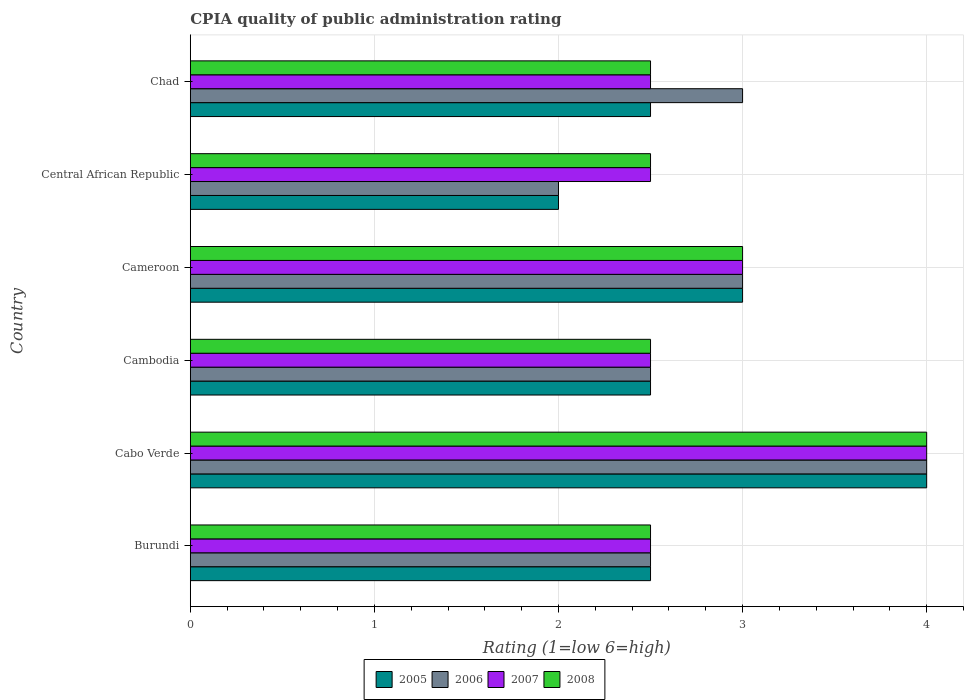How many different coloured bars are there?
Your response must be concise. 4. How many groups of bars are there?
Give a very brief answer. 6. Are the number of bars per tick equal to the number of legend labels?
Ensure brevity in your answer.  Yes. How many bars are there on the 6th tick from the bottom?
Give a very brief answer. 4. What is the label of the 2nd group of bars from the top?
Your answer should be very brief. Central African Republic. In how many cases, is the number of bars for a given country not equal to the number of legend labels?
Ensure brevity in your answer.  0. What is the CPIA rating in 2008 in Chad?
Ensure brevity in your answer.  2.5. Across all countries, what is the minimum CPIA rating in 2008?
Keep it short and to the point. 2.5. In which country was the CPIA rating in 2006 maximum?
Offer a terse response. Cabo Verde. In which country was the CPIA rating in 2007 minimum?
Offer a very short reply. Burundi. What is the difference between the CPIA rating in 2006 in Burundi and that in Cambodia?
Offer a very short reply. 0. What is the average CPIA rating in 2006 per country?
Offer a very short reply. 2.83. In how many countries, is the CPIA rating in 2007 greater than 2.6 ?
Offer a very short reply. 2. What is the ratio of the CPIA rating in 2005 in Central African Republic to that in Chad?
Make the answer very short. 0.8. Is the difference between the CPIA rating in 2008 in Cameroon and Chad greater than the difference between the CPIA rating in 2006 in Cameroon and Chad?
Give a very brief answer. Yes. What is the difference between the highest and the second highest CPIA rating in 2008?
Offer a terse response. 1. What is the difference between the highest and the lowest CPIA rating in 2005?
Make the answer very short. 2. Is it the case that in every country, the sum of the CPIA rating in 2007 and CPIA rating in 2006 is greater than the sum of CPIA rating in 2005 and CPIA rating in 2008?
Offer a very short reply. No. Is it the case that in every country, the sum of the CPIA rating in 2005 and CPIA rating in 2008 is greater than the CPIA rating in 2006?
Give a very brief answer. Yes. How many bars are there?
Keep it short and to the point. 24. How many countries are there in the graph?
Give a very brief answer. 6. What is the difference between two consecutive major ticks on the X-axis?
Give a very brief answer. 1. Where does the legend appear in the graph?
Offer a very short reply. Bottom center. How many legend labels are there?
Your answer should be very brief. 4. What is the title of the graph?
Ensure brevity in your answer.  CPIA quality of public administration rating. What is the Rating (1=low 6=high) in 2006 in Burundi?
Your answer should be compact. 2.5. What is the Rating (1=low 6=high) of 2007 in Burundi?
Provide a short and direct response. 2.5. What is the Rating (1=low 6=high) in 2005 in Cabo Verde?
Your answer should be compact. 4. What is the Rating (1=low 6=high) in 2006 in Cabo Verde?
Make the answer very short. 4. What is the Rating (1=low 6=high) in 2008 in Cabo Verde?
Your answer should be compact. 4. What is the Rating (1=low 6=high) in 2006 in Cambodia?
Provide a succinct answer. 2.5. What is the Rating (1=low 6=high) of 2006 in Cameroon?
Your answer should be compact. 3. What is the Rating (1=low 6=high) of 2007 in Cameroon?
Ensure brevity in your answer.  3. What is the Rating (1=low 6=high) in 2005 in Central African Republic?
Offer a terse response. 2. What is the Rating (1=low 6=high) in 2006 in Central African Republic?
Your answer should be very brief. 2. What is the Rating (1=low 6=high) of 2008 in Central African Republic?
Offer a very short reply. 2.5. What is the Rating (1=low 6=high) of 2005 in Chad?
Your answer should be compact. 2.5. What is the Rating (1=low 6=high) in 2006 in Chad?
Ensure brevity in your answer.  3. What is the Rating (1=low 6=high) of 2008 in Chad?
Make the answer very short. 2.5. Across all countries, what is the maximum Rating (1=low 6=high) of 2005?
Make the answer very short. 4. Across all countries, what is the maximum Rating (1=low 6=high) in 2006?
Give a very brief answer. 4. Across all countries, what is the minimum Rating (1=low 6=high) of 2005?
Offer a terse response. 2. Across all countries, what is the minimum Rating (1=low 6=high) in 2006?
Provide a succinct answer. 2. Across all countries, what is the minimum Rating (1=low 6=high) of 2008?
Offer a terse response. 2.5. What is the total Rating (1=low 6=high) of 2005 in the graph?
Ensure brevity in your answer.  16.5. What is the total Rating (1=low 6=high) in 2006 in the graph?
Give a very brief answer. 17. What is the total Rating (1=low 6=high) of 2008 in the graph?
Provide a succinct answer. 17. What is the difference between the Rating (1=low 6=high) in 2005 in Burundi and that in Cabo Verde?
Provide a short and direct response. -1.5. What is the difference between the Rating (1=low 6=high) in 2006 in Burundi and that in Cabo Verde?
Make the answer very short. -1.5. What is the difference between the Rating (1=low 6=high) of 2005 in Burundi and that in Cambodia?
Your answer should be compact. 0. What is the difference between the Rating (1=low 6=high) of 2005 in Burundi and that in Cameroon?
Give a very brief answer. -0.5. What is the difference between the Rating (1=low 6=high) of 2007 in Burundi and that in Cameroon?
Your response must be concise. -0.5. What is the difference between the Rating (1=low 6=high) in 2005 in Burundi and that in Central African Republic?
Make the answer very short. 0.5. What is the difference between the Rating (1=low 6=high) in 2005 in Burundi and that in Chad?
Give a very brief answer. 0. What is the difference between the Rating (1=low 6=high) in 2006 in Burundi and that in Chad?
Your response must be concise. -0.5. What is the difference between the Rating (1=low 6=high) in 2007 in Burundi and that in Chad?
Offer a very short reply. 0. What is the difference between the Rating (1=low 6=high) in 2008 in Burundi and that in Chad?
Your response must be concise. 0. What is the difference between the Rating (1=low 6=high) in 2005 in Cabo Verde and that in Cambodia?
Keep it short and to the point. 1.5. What is the difference between the Rating (1=low 6=high) of 2006 in Cabo Verde and that in Cambodia?
Your answer should be very brief. 1.5. What is the difference between the Rating (1=low 6=high) of 2006 in Cabo Verde and that in Cameroon?
Your answer should be compact. 1. What is the difference between the Rating (1=low 6=high) of 2007 in Cabo Verde and that in Cameroon?
Give a very brief answer. 1. What is the difference between the Rating (1=low 6=high) of 2005 in Cabo Verde and that in Central African Republic?
Your answer should be compact. 2. What is the difference between the Rating (1=low 6=high) of 2007 in Cabo Verde and that in Central African Republic?
Offer a terse response. 1.5. What is the difference between the Rating (1=low 6=high) of 2008 in Cabo Verde and that in Central African Republic?
Provide a short and direct response. 1.5. What is the difference between the Rating (1=low 6=high) of 2007 in Cabo Verde and that in Chad?
Offer a terse response. 1.5. What is the difference between the Rating (1=low 6=high) in 2006 in Cambodia and that in Cameroon?
Make the answer very short. -0.5. What is the difference between the Rating (1=low 6=high) in 2007 in Cambodia and that in Cameroon?
Your answer should be compact. -0.5. What is the difference between the Rating (1=low 6=high) in 2005 in Cambodia and that in Central African Republic?
Make the answer very short. 0.5. What is the difference between the Rating (1=low 6=high) of 2006 in Cambodia and that in Central African Republic?
Keep it short and to the point. 0.5. What is the difference between the Rating (1=low 6=high) in 2008 in Cambodia and that in Chad?
Make the answer very short. 0. What is the difference between the Rating (1=low 6=high) in 2006 in Cameroon and that in Central African Republic?
Your response must be concise. 1. What is the difference between the Rating (1=low 6=high) of 2005 in Cameroon and that in Chad?
Your answer should be compact. 0.5. What is the difference between the Rating (1=low 6=high) in 2006 in Cameroon and that in Chad?
Provide a short and direct response. 0. What is the difference between the Rating (1=low 6=high) in 2007 in Cameroon and that in Chad?
Provide a short and direct response. 0.5. What is the difference between the Rating (1=low 6=high) of 2008 in Cameroon and that in Chad?
Keep it short and to the point. 0.5. What is the difference between the Rating (1=low 6=high) in 2007 in Central African Republic and that in Chad?
Ensure brevity in your answer.  0. What is the difference between the Rating (1=low 6=high) of 2005 in Burundi and the Rating (1=low 6=high) of 2007 in Cabo Verde?
Offer a very short reply. -1.5. What is the difference between the Rating (1=low 6=high) of 2006 in Burundi and the Rating (1=low 6=high) of 2008 in Cabo Verde?
Provide a succinct answer. -1.5. What is the difference between the Rating (1=low 6=high) in 2007 in Burundi and the Rating (1=low 6=high) in 2008 in Cabo Verde?
Offer a very short reply. -1.5. What is the difference between the Rating (1=low 6=high) of 2006 in Burundi and the Rating (1=low 6=high) of 2008 in Cambodia?
Provide a succinct answer. 0. What is the difference between the Rating (1=low 6=high) in 2007 in Burundi and the Rating (1=low 6=high) in 2008 in Cambodia?
Make the answer very short. 0. What is the difference between the Rating (1=low 6=high) in 2005 in Burundi and the Rating (1=low 6=high) in 2006 in Cameroon?
Make the answer very short. -0.5. What is the difference between the Rating (1=low 6=high) in 2005 in Burundi and the Rating (1=low 6=high) in 2008 in Cameroon?
Make the answer very short. -0.5. What is the difference between the Rating (1=low 6=high) of 2005 in Burundi and the Rating (1=low 6=high) of 2007 in Chad?
Offer a very short reply. 0. What is the difference between the Rating (1=low 6=high) of 2005 in Burundi and the Rating (1=low 6=high) of 2008 in Chad?
Give a very brief answer. 0. What is the difference between the Rating (1=low 6=high) in 2006 in Burundi and the Rating (1=low 6=high) in 2007 in Chad?
Provide a succinct answer. 0. What is the difference between the Rating (1=low 6=high) in 2006 in Burundi and the Rating (1=low 6=high) in 2008 in Chad?
Your answer should be compact. 0. What is the difference between the Rating (1=low 6=high) in 2005 in Cabo Verde and the Rating (1=low 6=high) in 2006 in Cambodia?
Ensure brevity in your answer.  1.5. What is the difference between the Rating (1=low 6=high) in 2005 in Cabo Verde and the Rating (1=low 6=high) in 2008 in Cambodia?
Offer a very short reply. 1.5. What is the difference between the Rating (1=low 6=high) of 2006 in Cabo Verde and the Rating (1=low 6=high) of 2007 in Cambodia?
Provide a short and direct response. 1.5. What is the difference between the Rating (1=low 6=high) of 2006 in Cabo Verde and the Rating (1=low 6=high) of 2008 in Cambodia?
Your response must be concise. 1.5. What is the difference between the Rating (1=low 6=high) in 2007 in Cabo Verde and the Rating (1=low 6=high) in 2008 in Cambodia?
Your response must be concise. 1.5. What is the difference between the Rating (1=low 6=high) of 2005 in Cabo Verde and the Rating (1=low 6=high) of 2007 in Cameroon?
Keep it short and to the point. 1. What is the difference between the Rating (1=low 6=high) of 2006 in Cabo Verde and the Rating (1=low 6=high) of 2007 in Cameroon?
Your answer should be compact. 1. What is the difference between the Rating (1=low 6=high) of 2006 in Cabo Verde and the Rating (1=low 6=high) of 2008 in Cameroon?
Provide a succinct answer. 1. What is the difference between the Rating (1=low 6=high) in 2005 in Cabo Verde and the Rating (1=low 6=high) in 2008 in Central African Republic?
Your answer should be compact. 1.5. What is the difference between the Rating (1=low 6=high) of 2006 in Cabo Verde and the Rating (1=low 6=high) of 2008 in Central African Republic?
Offer a terse response. 1.5. What is the difference between the Rating (1=low 6=high) in 2005 in Cabo Verde and the Rating (1=low 6=high) in 2006 in Chad?
Keep it short and to the point. 1. What is the difference between the Rating (1=low 6=high) in 2005 in Cabo Verde and the Rating (1=low 6=high) in 2007 in Chad?
Offer a very short reply. 1.5. What is the difference between the Rating (1=low 6=high) in 2006 in Cabo Verde and the Rating (1=low 6=high) in 2008 in Chad?
Ensure brevity in your answer.  1.5. What is the difference between the Rating (1=low 6=high) in 2005 in Cambodia and the Rating (1=low 6=high) in 2006 in Cameroon?
Ensure brevity in your answer.  -0.5. What is the difference between the Rating (1=low 6=high) of 2005 in Cambodia and the Rating (1=low 6=high) of 2007 in Cameroon?
Your answer should be compact. -0.5. What is the difference between the Rating (1=low 6=high) in 2006 in Cambodia and the Rating (1=low 6=high) in 2007 in Cameroon?
Offer a terse response. -0.5. What is the difference between the Rating (1=low 6=high) of 2007 in Cambodia and the Rating (1=low 6=high) of 2008 in Cameroon?
Offer a terse response. -0.5. What is the difference between the Rating (1=low 6=high) in 2005 in Cambodia and the Rating (1=low 6=high) in 2006 in Central African Republic?
Provide a short and direct response. 0.5. What is the difference between the Rating (1=low 6=high) in 2005 in Cambodia and the Rating (1=low 6=high) in 2007 in Central African Republic?
Your response must be concise. 0. What is the difference between the Rating (1=low 6=high) of 2006 in Cambodia and the Rating (1=low 6=high) of 2008 in Central African Republic?
Ensure brevity in your answer.  0. What is the difference between the Rating (1=low 6=high) in 2005 in Cambodia and the Rating (1=low 6=high) in 2006 in Chad?
Your answer should be compact. -0.5. What is the difference between the Rating (1=low 6=high) of 2005 in Cambodia and the Rating (1=low 6=high) of 2007 in Chad?
Keep it short and to the point. 0. What is the difference between the Rating (1=low 6=high) of 2005 in Cambodia and the Rating (1=low 6=high) of 2008 in Chad?
Your response must be concise. 0. What is the difference between the Rating (1=low 6=high) in 2006 in Cambodia and the Rating (1=low 6=high) in 2007 in Chad?
Make the answer very short. 0. What is the difference between the Rating (1=low 6=high) in 2006 in Cambodia and the Rating (1=low 6=high) in 2008 in Chad?
Offer a very short reply. 0. What is the difference between the Rating (1=low 6=high) in 2007 in Cambodia and the Rating (1=low 6=high) in 2008 in Chad?
Offer a terse response. 0. What is the difference between the Rating (1=low 6=high) in 2005 in Cameroon and the Rating (1=low 6=high) in 2006 in Central African Republic?
Provide a short and direct response. 1. What is the difference between the Rating (1=low 6=high) of 2005 in Cameroon and the Rating (1=low 6=high) of 2008 in Central African Republic?
Offer a terse response. 0.5. What is the difference between the Rating (1=low 6=high) in 2006 in Cameroon and the Rating (1=low 6=high) in 2007 in Central African Republic?
Your answer should be very brief. 0.5. What is the difference between the Rating (1=low 6=high) of 2006 in Cameroon and the Rating (1=low 6=high) of 2008 in Central African Republic?
Your response must be concise. 0.5. What is the difference between the Rating (1=low 6=high) in 2007 in Cameroon and the Rating (1=low 6=high) in 2008 in Central African Republic?
Provide a succinct answer. 0.5. What is the difference between the Rating (1=low 6=high) in 2005 in Cameroon and the Rating (1=low 6=high) in 2007 in Chad?
Ensure brevity in your answer.  0.5. What is the difference between the Rating (1=low 6=high) of 2006 in Cameroon and the Rating (1=low 6=high) of 2008 in Chad?
Offer a terse response. 0.5. What is the difference between the Rating (1=low 6=high) in 2007 in Cameroon and the Rating (1=low 6=high) in 2008 in Chad?
Keep it short and to the point. 0.5. What is the difference between the Rating (1=low 6=high) in 2005 in Central African Republic and the Rating (1=low 6=high) in 2007 in Chad?
Provide a short and direct response. -0.5. What is the difference between the Rating (1=low 6=high) in 2005 in Central African Republic and the Rating (1=low 6=high) in 2008 in Chad?
Offer a terse response. -0.5. What is the difference between the Rating (1=low 6=high) in 2006 in Central African Republic and the Rating (1=low 6=high) in 2007 in Chad?
Your answer should be very brief. -0.5. What is the average Rating (1=low 6=high) in 2005 per country?
Your answer should be compact. 2.75. What is the average Rating (1=low 6=high) in 2006 per country?
Ensure brevity in your answer.  2.83. What is the average Rating (1=low 6=high) in 2007 per country?
Ensure brevity in your answer.  2.83. What is the average Rating (1=low 6=high) in 2008 per country?
Give a very brief answer. 2.83. What is the difference between the Rating (1=low 6=high) of 2005 and Rating (1=low 6=high) of 2008 in Burundi?
Your answer should be very brief. 0. What is the difference between the Rating (1=low 6=high) of 2006 and Rating (1=low 6=high) of 2007 in Burundi?
Your response must be concise. 0. What is the difference between the Rating (1=low 6=high) of 2006 and Rating (1=low 6=high) of 2008 in Burundi?
Your answer should be compact. 0. What is the difference between the Rating (1=low 6=high) in 2007 and Rating (1=low 6=high) in 2008 in Burundi?
Ensure brevity in your answer.  0. What is the difference between the Rating (1=low 6=high) of 2005 and Rating (1=low 6=high) of 2006 in Cabo Verde?
Offer a very short reply. 0. What is the difference between the Rating (1=low 6=high) of 2005 and Rating (1=low 6=high) of 2008 in Cabo Verde?
Make the answer very short. 0. What is the difference between the Rating (1=low 6=high) of 2006 and Rating (1=low 6=high) of 2007 in Cabo Verde?
Your answer should be compact. 0. What is the difference between the Rating (1=low 6=high) of 2006 and Rating (1=low 6=high) of 2008 in Cabo Verde?
Ensure brevity in your answer.  0. What is the difference between the Rating (1=low 6=high) in 2005 and Rating (1=low 6=high) in 2006 in Cambodia?
Provide a short and direct response. 0. What is the difference between the Rating (1=low 6=high) in 2005 and Rating (1=low 6=high) in 2008 in Cambodia?
Provide a succinct answer. 0. What is the difference between the Rating (1=low 6=high) of 2005 and Rating (1=low 6=high) of 2008 in Cameroon?
Offer a terse response. 0. What is the difference between the Rating (1=low 6=high) of 2006 and Rating (1=low 6=high) of 2007 in Cameroon?
Provide a short and direct response. 0. What is the difference between the Rating (1=low 6=high) in 2007 and Rating (1=low 6=high) in 2008 in Cameroon?
Provide a short and direct response. 0. What is the difference between the Rating (1=low 6=high) in 2005 and Rating (1=low 6=high) in 2006 in Central African Republic?
Give a very brief answer. 0. What is the difference between the Rating (1=low 6=high) of 2005 and Rating (1=low 6=high) of 2007 in Central African Republic?
Provide a short and direct response. -0.5. What is the difference between the Rating (1=low 6=high) in 2005 and Rating (1=low 6=high) in 2006 in Chad?
Give a very brief answer. -0.5. What is the difference between the Rating (1=low 6=high) of 2005 and Rating (1=low 6=high) of 2007 in Chad?
Make the answer very short. 0. What is the difference between the Rating (1=low 6=high) of 2005 and Rating (1=low 6=high) of 2008 in Chad?
Provide a succinct answer. 0. What is the difference between the Rating (1=low 6=high) in 2006 and Rating (1=low 6=high) in 2008 in Chad?
Give a very brief answer. 0.5. What is the difference between the Rating (1=low 6=high) in 2007 and Rating (1=low 6=high) in 2008 in Chad?
Offer a terse response. 0. What is the ratio of the Rating (1=low 6=high) of 2005 in Burundi to that in Cabo Verde?
Keep it short and to the point. 0.62. What is the ratio of the Rating (1=low 6=high) of 2006 in Burundi to that in Cabo Verde?
Ensure brevity in your answer.  0.62. What is the ratio of the Rating (1=low 6=high) in 2008 in Burundi to that in Cabo Verde?
Make the answer very short. 0.62. What is the ratio of the Rating (1=low 6=high) of 2006 in Burundi to that in Cambodia?
Offer a very short reply. 1. What is the ratio of the Rating (1=low 6=high) of 2008 in Burundi to that in Cambodia?
Ensure brevity in your answer.  1. What is the ratio of the Rating (1=low 6=high) in 2006 in Burundi to that in Cameroon?
Your answer should be very brief. 0.83. What is the ratio of the Rating (1=low 6=high) of 2007 in Burundi to that in Cameroon?
Offer a terse response. 0.83. What is the ratio of the Rating (1=low 6=high) in 2007 in Burundi to that in Central African Republic?
Provide a succinct answer. 1. What is the ratio of the Rating (1=low 6=high) in 2008 in Burundi to that in Central African Republic?
Ensure brevity in your answer.  1. What is the ratio of the Rating (1=low 6=high) of 2005 in Burundi to that in Chad?
Your response must be concise. 1. What is the ratio of the Rating (1=low 6=high) in 2007 in Burundi to that in Chad?
Your answer should be compact. 1. What is the ratio of the Rating (1=low 6=high) in 2008 in Burundi to that in Chad?
Provide a succinct answer. 1. What is the ratio of the Rating (1=low 6=high) in 2008 in Cabo Verde to that in Cambodia?
Ensure brevity in your answer.  1.6. What is the ratio of the Rating (1=low 6=high) in 2006 in Cabo Verde to that in Central African Republic?
Your answer should be compact. 2. What is the ratio of the Rating (1=low 6=high) of 2007 in Cabo Verde to that in Central African Republic?
Provide a succinct answer. 1.6. What is the ratio of the Rating (1=low 6=high) in 2006 in Cabo Verde to that in Chad?
Provide a succinct answer. 1.33. What is the ratio of the Rating (1=low 6=high) in 2007 in Cabo Verde to that in Chad?
Give a very brief answer. 1.6. What is the ratio of the Rating (1=low 6=high) of 2005 in Cambodia to that in Cameroon?
Make the answer very short. 0.83. What is the ratio of the Rating (1=low 6=high) in 2006 in Cambodia to that in Cameroon?
Provide a succinct answer. 0.83. What is the ratio of the Rating (1=low 6=high) in 2007 in Cambodia to that in Cameroon?
Keep it short and to the point. 0.83. What is the ratio of the Rating (1=low 6=high) in 2008 in Cambodia to that in Cameroon?
Provide a succinct answer. 0.83. What is the ratio of the Rating (1=low 6=high) in 2006 in Cambodia to that in Chad?
Provide a succinct answer. 0.83. What is the ratio of the Rating (1=low 6=high) of 2008 in Cambodia to that in Chad?
Offer a very short reply. 1. What is the ratio of the Rating (1=low 6=high) in 2005 in Cameroon to that in Central African Republic?
Offer a very short reply. 1.5. What is the ratio of the Rating (1=low 6=high) in 2007 in Cameroon to that in Central African Republic?
Give a very brief answer. 1.2. What is the ratio of the Rating (1=low 6=high) in 2008 in Cameroon to that in Central African Republic?
Your response must be concise. 1.2. What is the ratio of the Rating (1=low 6=high) in 2006 in Cameroon to that in Chad?
Ensure brevity in your answer.  1. What is the ratio of the Rating (1=low 6=high) in 2008 in Cameroon to that in Chad?
Keep it short and to the point. 1.2. What is the ratio of the Rating (1=low 6=high) of 2005 in Central African Republic to that in Chad?
Provide a succinct answer. 0.8. What is the ratio of the Rating (1=low 6=high) in 2006 in Central African Republic to that in Chad?
Provide a short and direct response. 0.67. What is the ratio of the Rating (1=low 6=high) in 2007 in Central African Republic to that in Chad?
Make the answer very short. 1. What is the difference between the highest and the second highest Rating (1=low 6=high) in 2005?
Your answer should be compact. 1. What is the difference between the highest and the second highest Rating (1=low 6=high) in 2007?
Make the answer very short. 1. What is the difference between the highest and the second highest Rating (1=low 6=high) of 2008?
Your answer should be very brief. 1. What is the difference between the highest and the lowest Rating (1=low 6=high) in 2005?
Make the answer very short. 2. What is the difference between the highest and the lowest Rating (1=low 6=high) of 2006?
Offer a terse response. 2. What is the difference between the highest and the lowest Rating (1=low 6=high) of 2008?
Provide a succinct answer. 1.5. 